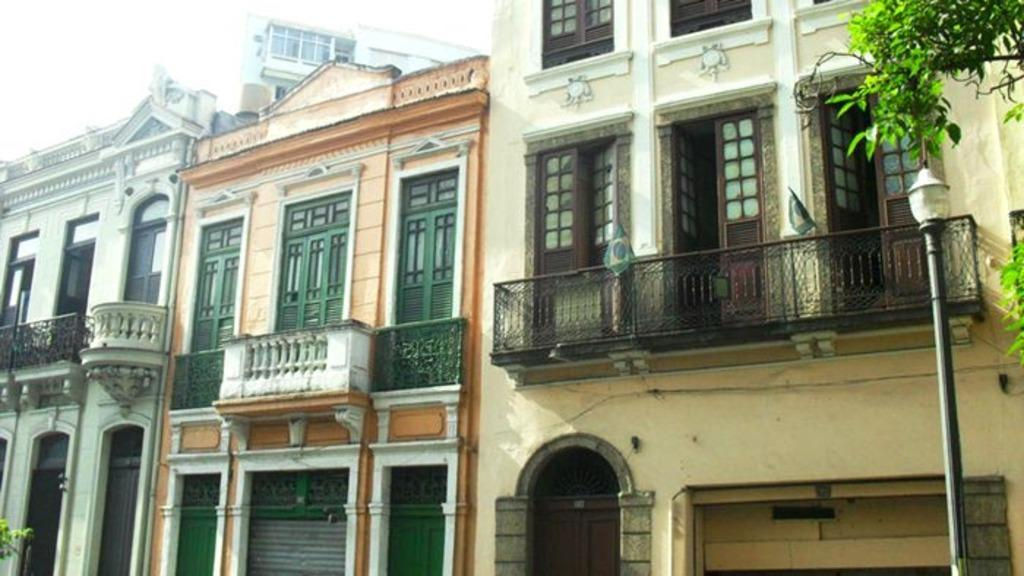What type of structures are visible in the image? There are buildings with balconies in the image. Where is the street light located in the image? The street light is on the right side of the image. What can be seen in the top right corner of the image? There are trees in the top right corner of the image. What is visible in the top left corner of the image? The sky is visible in the top left corner of the image. What arithmetic problem is being solved on the balcony of the building in the image? There is no arithmetic problem visible in the image; it only shows buildings with balconies, a street light, trees, and the sky. 